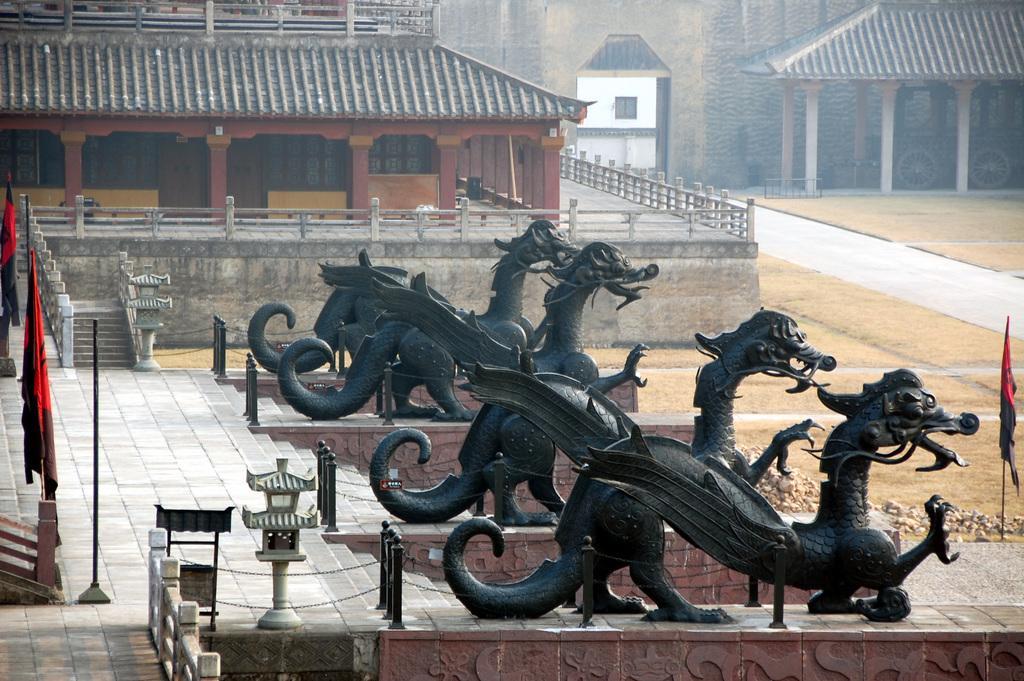In one or two sentences, can you explain what this image depicts? This image is taken outdoors. In the middle of the image there are a few sculptures of chinese dragons and there are a few stairs and railings. In the background there are two chinese architectures with walls, roofs, pillars, windows and doors. There is a railing. On the left side of the image there are a few flags. On the right side of the image there is a ground and there is a flag. 